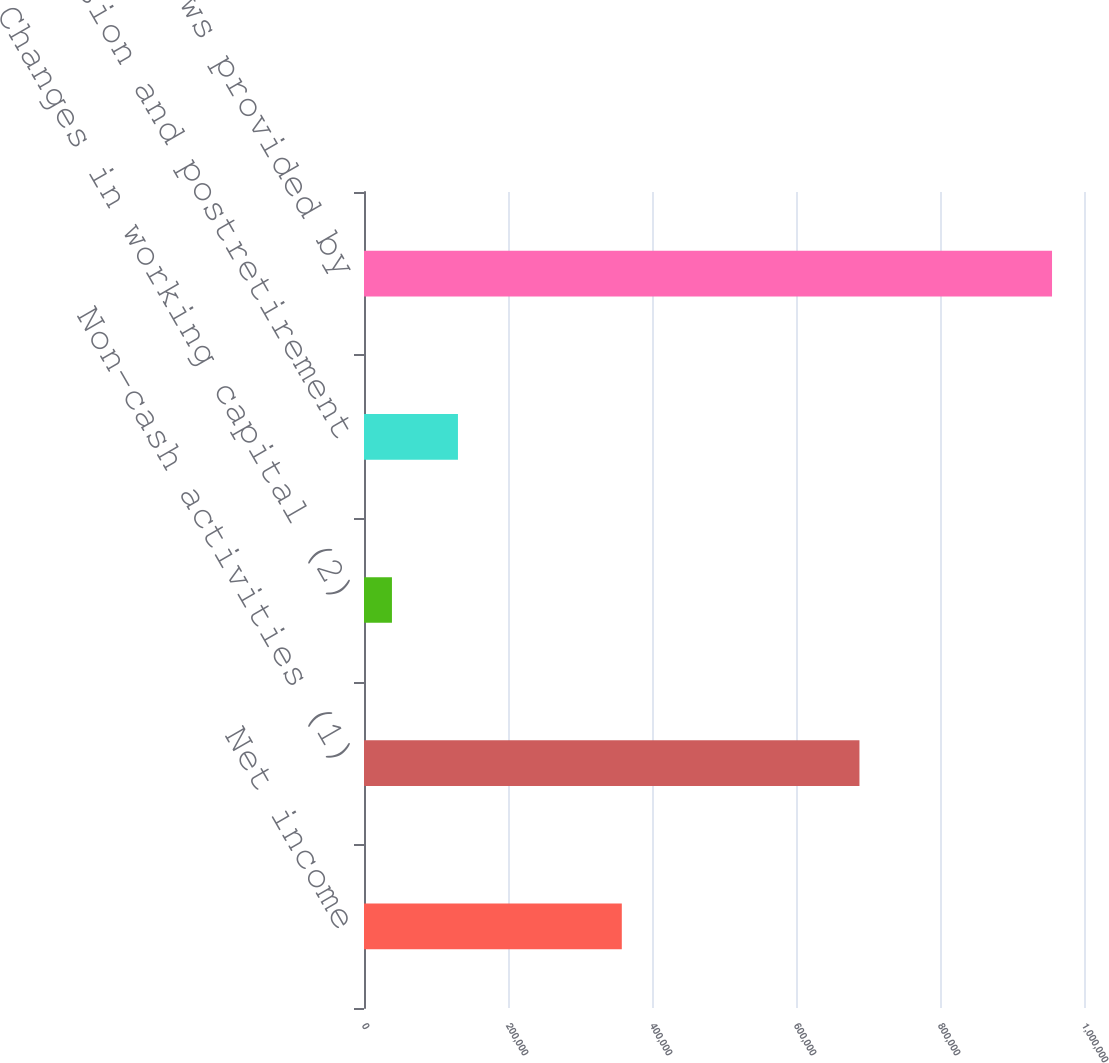Convert chart to OTSL. <chart><loc_0><loc_0><loc_500><loc_500><bar_chart><fcel>Net income<fcel>Non-cash activities (1)<fcel>Changes in working capital (2)<fcel>Pension and postretirement<fcel>Net cash flows provided by<nl><fcel>358070<fcel>688126<fcel>38812<fcel>130491<fcel>955598<nl></chart> 